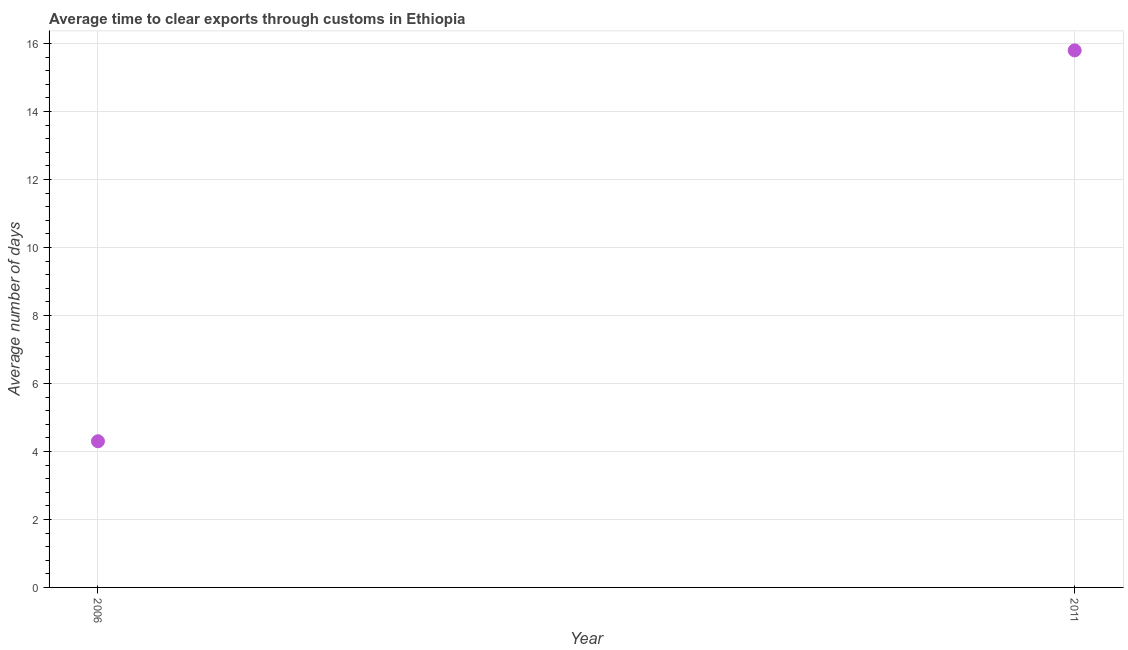What is the time to clear exports through customs in 2011?
Provide a short and direct response. 15.8. In which year was the time to clear exports through customs maximum?
Your answer should be very brief. 2011. What is the sum of the time to clear exports through customs?
Your answer should be very brief. 20.1. What is the average time to clear exports through customs per year?
Provide a succinct answer. 10.05. What is the median time to clear exports through customs?
Your answer should be compact. 10.05. Do a majority of the years between 2006 and 2011 (inclusive) have time to clear exports through customs greater than 14.4 days?
Offer a terse response. No. What is the ratio of the time to clear exports through customs in 2006 to that in 2011?
Offer a terse response. 0.27. Is the time to clear exports through customs in 2006 less than that in 2011?
Ensure brevity in your answer.  Yes. How many dotlines are there?
Your answer should be very brief. 1. How many years are there in the graph?
Your response must be concise. 2. What is the difference between two consecutive major ticks on the Y-axis?
Provide a short and direct response. 2. Does the graph contain grids?
Offer a very short reply. Yes. What is the title of the graph?
Ensure brevity in your answer.  Average time to clear exports through customs in Ethiopia. What is the label or title of the Y-axis?
Offer a very short reply. Average number of days. What is the Average number of days in 2006?
Ensure brevity in your answer.  4.3. What is the difference between the Average number of days in 2006 and 2011?
Your answer should be compact. -11.5. What is the ratio of the Average number of days in 2006 to that in 2011?
Your answer should be compact. 0.27. 